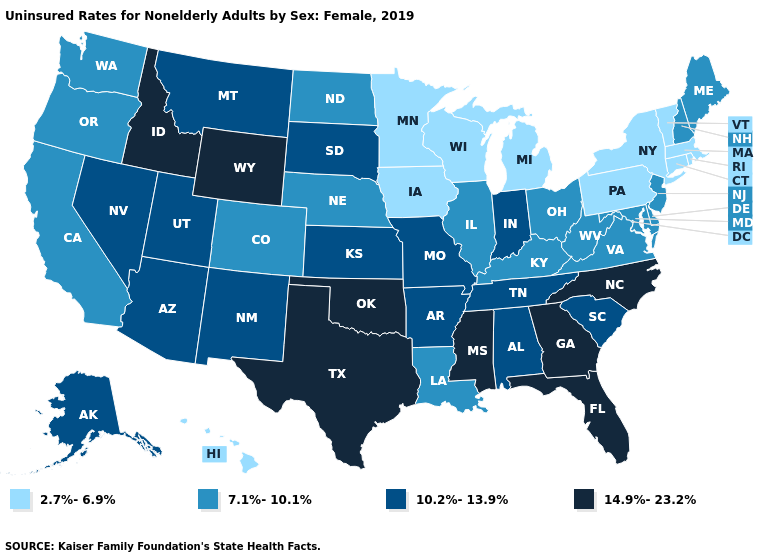Name the states that have a value in the range 2.7%-6.9%?
Concise answer only. Connecticut, Hawaii, Iowa, Massachusetts, Michigan, Minnesota, New York, Pennsylvania, Rhode Island, Vermont, Wisconsin. What is the value of North Dakota?
Give a very brief answer. 7.1%-10.1%. Name the states that have a value in the range 14.9%-23.2%?
Quick response, please. Florida, Georgia, Idaho, Mississippi, North Carolina, Oklahoma, Texas, Wyoming. What is the value of Utah?
Answer briefly. 10.2%-13.9%. Name the states that have a value in the range 14.9%-23.2%?
Give a very brief answer. Florida, Georgia, Idaho, Mississippi, North Carolina, Oklahoma, Texas, Wyoming. Does Washington have a lower value than Indiana?
Be succinct. Yes. What is the lowest value in states that border Rhode Island?
Be succinct. 2.7%-6.9%. Does Arizona have a higher value than Ohio?
Keep it brief. Yes. What is the lowest value in the South?
Write a very short answer. 7.1%-10.1%. What is the lowest value in the USA?
Quick response, please. 2.7%-6.9%. Does Utah have the lowest value in the West?
Concise answer only. No. What is the highest value in the USA?
Be succinct. 14.9%-23.2%. Does Massachusetts have the lowest value in the USA?
Keep it brief. Yes. Name the states that have a value in the range 14.9%-23.2%?
Be succinct. Florida, Georgia, Idaho, Mississippi, North Carolina, Oklahoma, Texas, Wyoming. Does Mississippi have the highest value in the USA?
Keep it brief. Yes. 